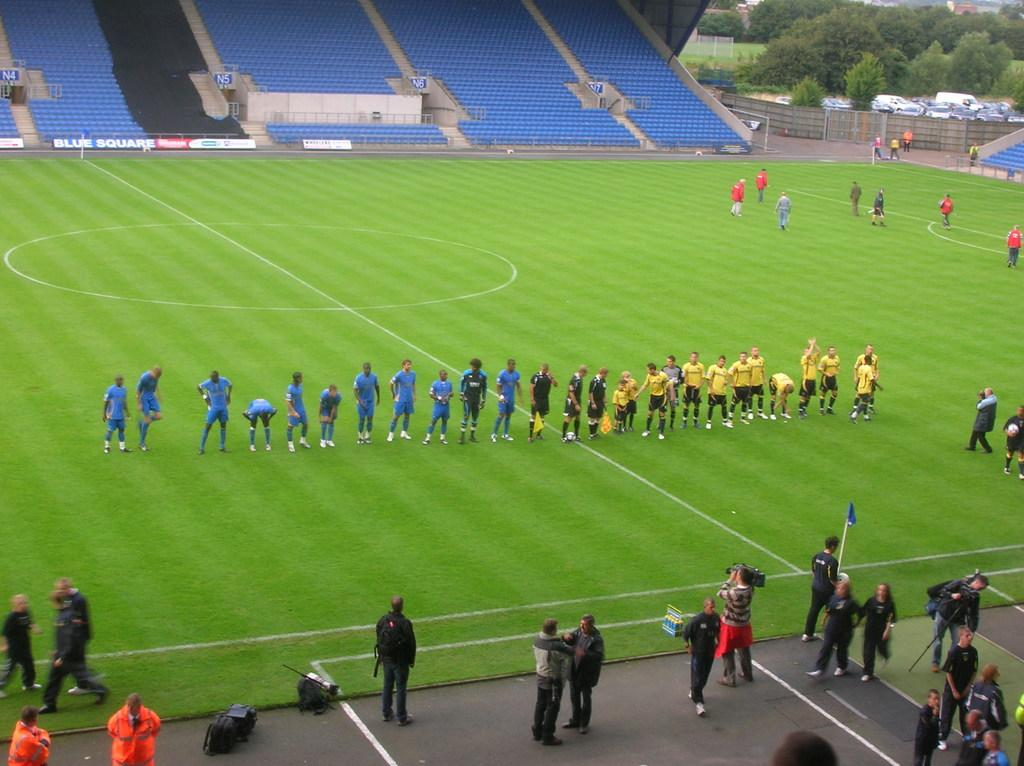What are the people in the image doing? The people in the image are standing on the ground. What are the people wearing? The people are wearing blue and yellow jerseys. What else can be seen in the image besides the people? There are empty chairs and trees in the image. Can you see any clouds in the image? There is no mention of clouds in the provided facts, so we cannot determine if they are present in the image. 